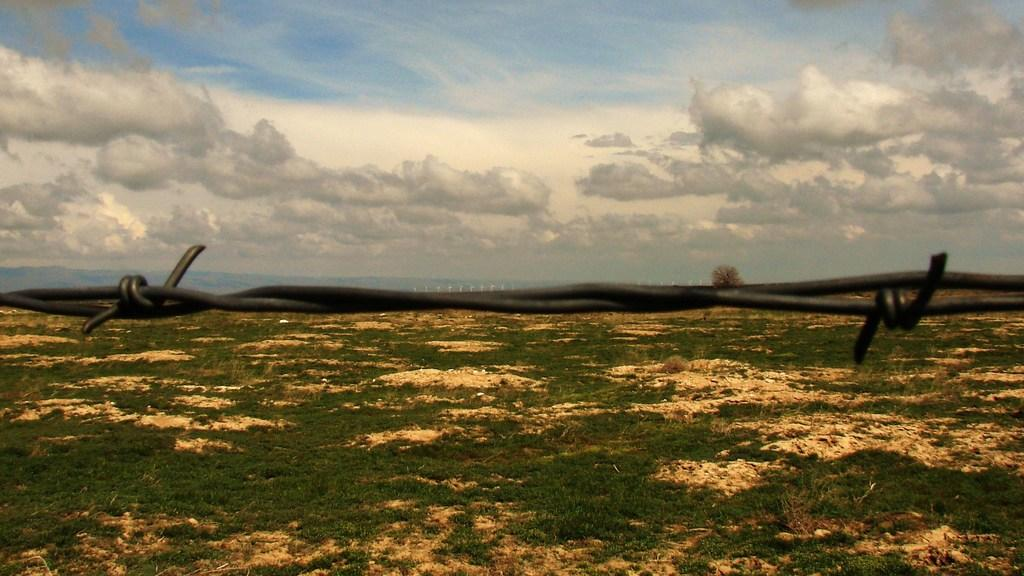What is the main object in the image? There is a metal wire in the image. What can be seen in the background of the image? There is grass and a tree in the background of the image. How would you describe the sky in the image? The sky is cloudy and visible at the top of the image. What type of cast can be seen on the tree in the image? There is no cast present on the tree in the image. What is the rate of growth for the grass in the image? The rate of growth for the grass cannot be determined from the image. 